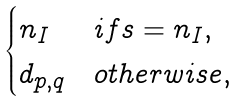<formula> <loc_0><loc_0><loc_500><loc_500>\begin{cases} n _ { I } & i f s = n _ { I } , \\ d _ { p , q } & o t h e r w i s e , \end{cases}</formula> 